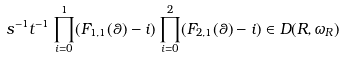<formula> <loc_0><loc_0><loc_500><loc_500>s ^ { - 1 } t ^ { - 1 } \prod _ { i = 0 } ^ { 1 } ( F _ { 1 , 1 } ( \theta ) - i ) \prod _ { i = 0 } ^ { 2 } ( F _ { 2 , 1 } ( \theta ) - i ) \in D ( R , \omega _ { R } )</formula> 